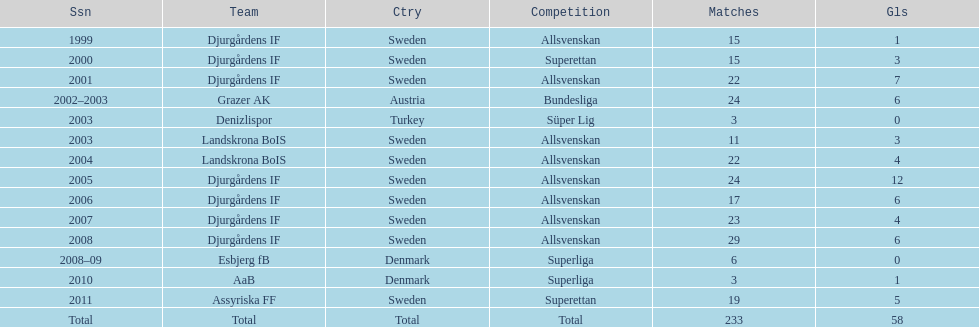What country is team djurgårdens if not from? Sweden. 